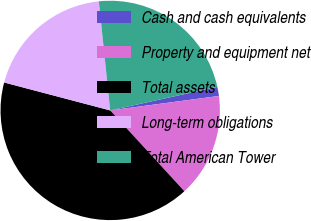Convert chart to OTSL. <chart><loc_0><loc_0><loc_500><loc_500><pie_chart><fcel>Cash and cash equivalents<fcel>Property and equipment net<fcel>Total assets<fcel>Long-term obligations<fcel>Total American Tower<nl><fcel>1.34%<fcel>15.29%<fcel>40.92%<fcel>19.25%<fcel>23.21%<nl></chart> 